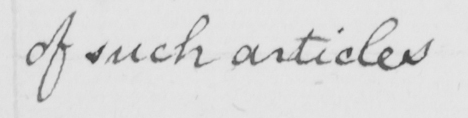Can you tell me what this handwritten text says? of such articles 